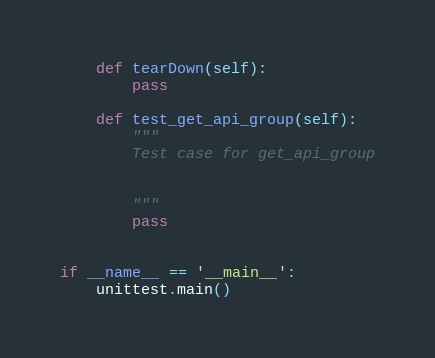<code> <loc_0><loc_0><loc_500><loc_500><_Python_>
    def tearDown(self):
        pass

    def test_get_api_group(self):
        """
        Test case for get_api_group

        
        """
        pass


if __name__ == '__main__':
    unittest.main()
</code> 